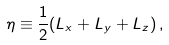Convert formula to latex. <formula><loc_0><loc_0><loc_500><loc_500>\eta \equiv \frac { 1 } { 2 } ( L _ { x } + L _ { y } + L _ { z } ) \, ,</formula> 